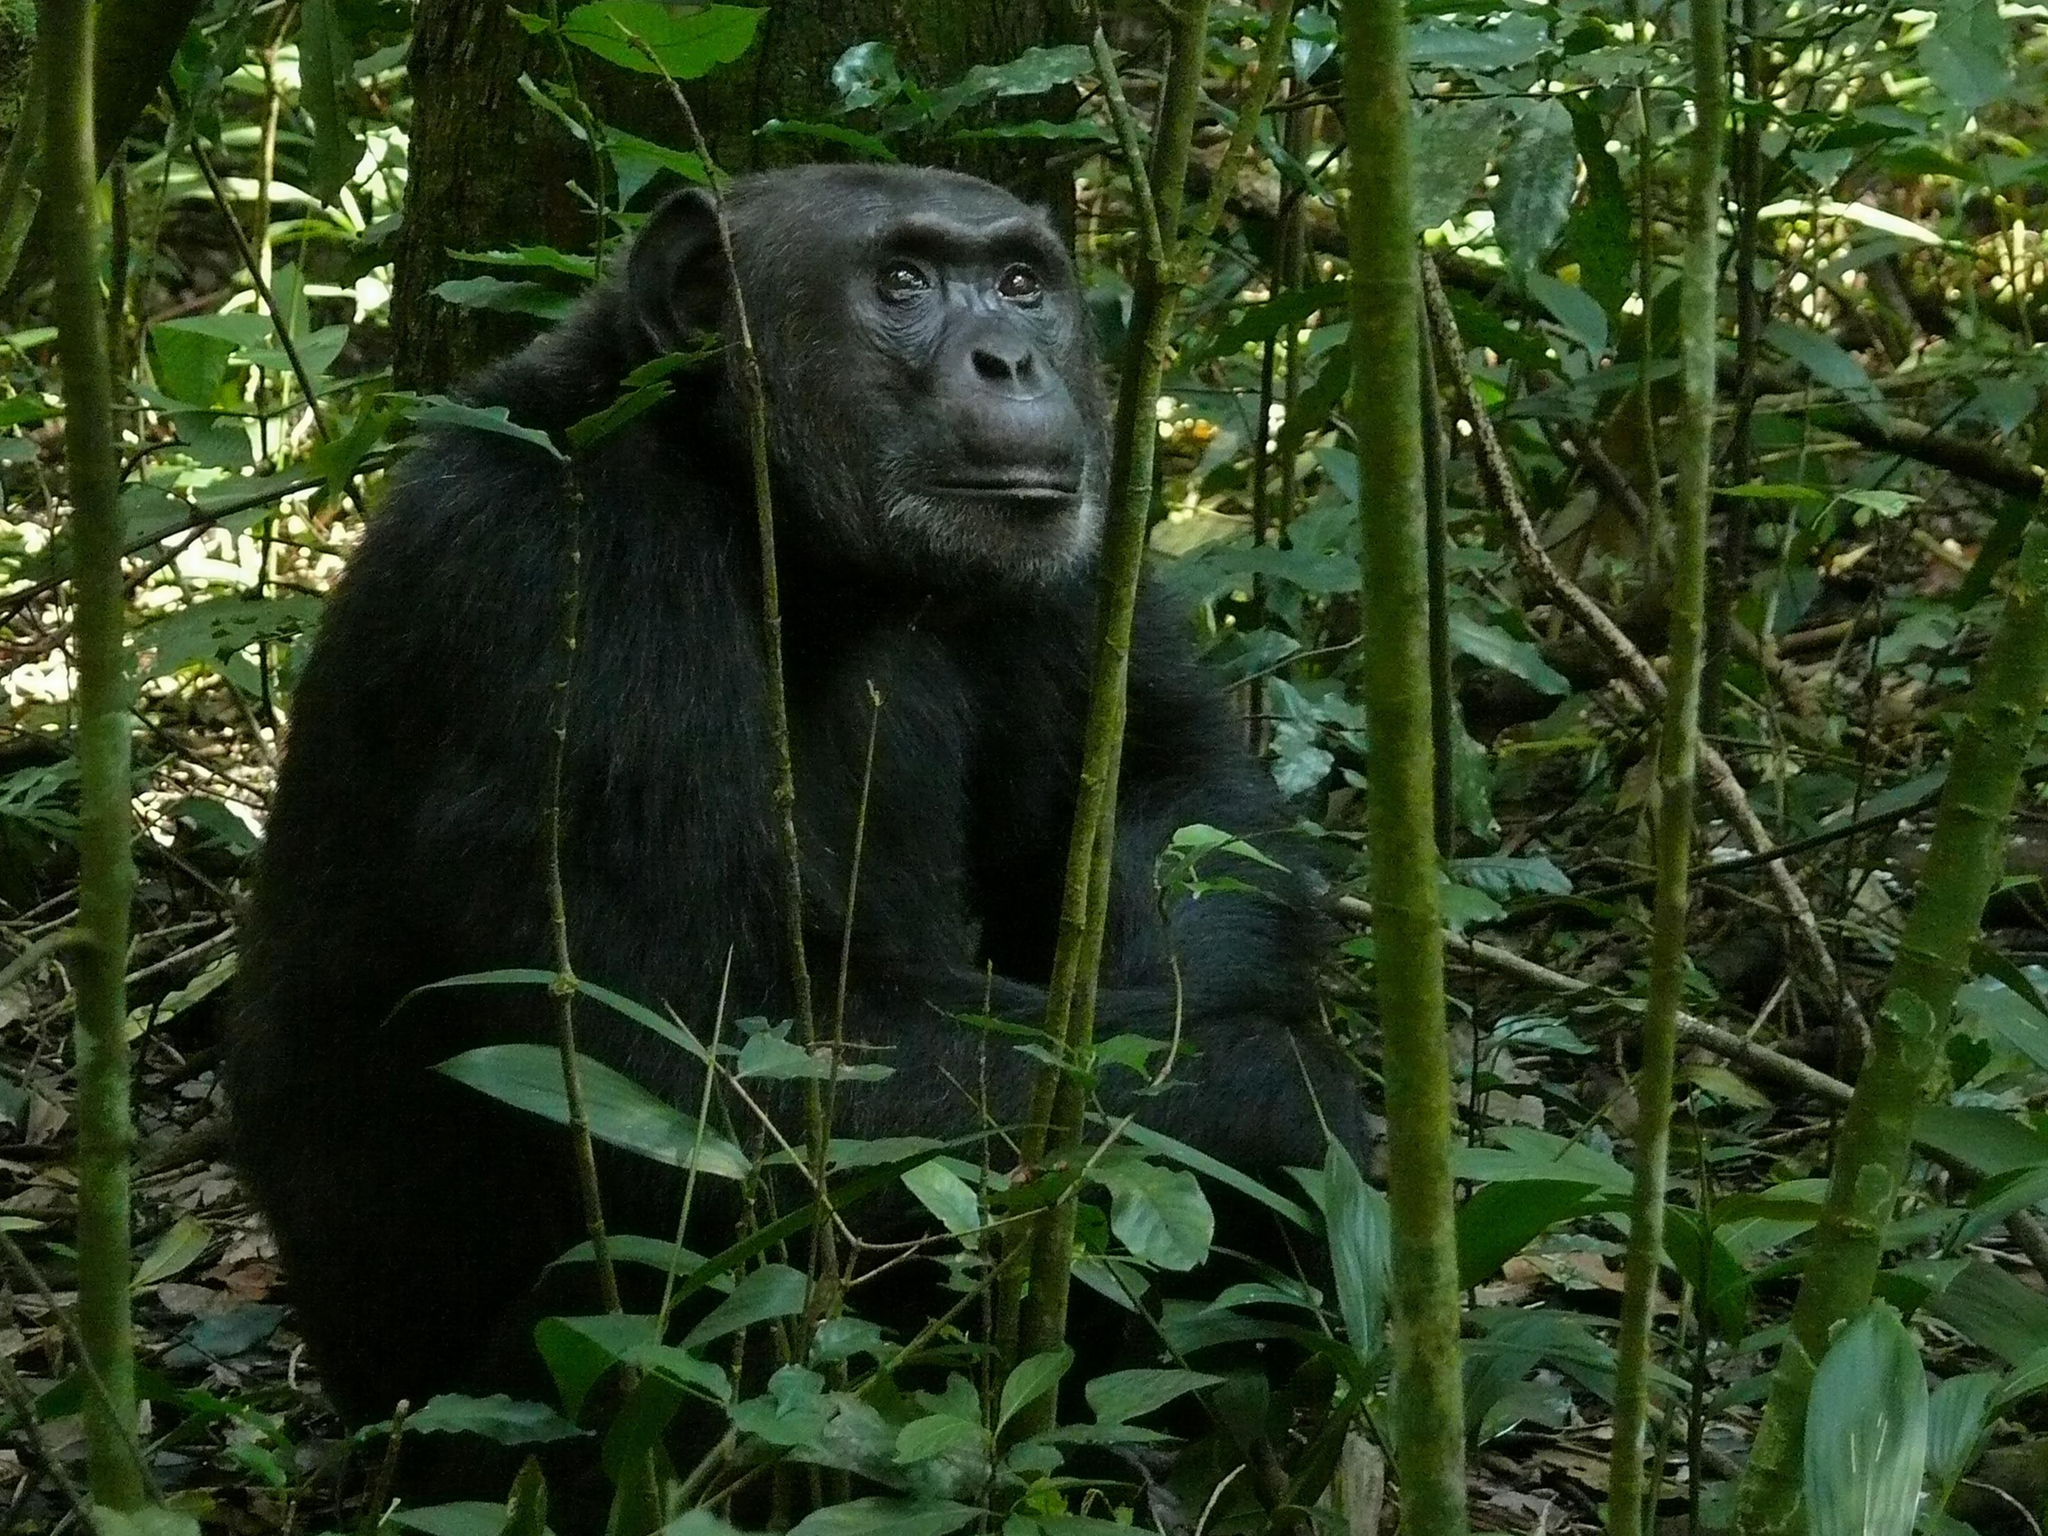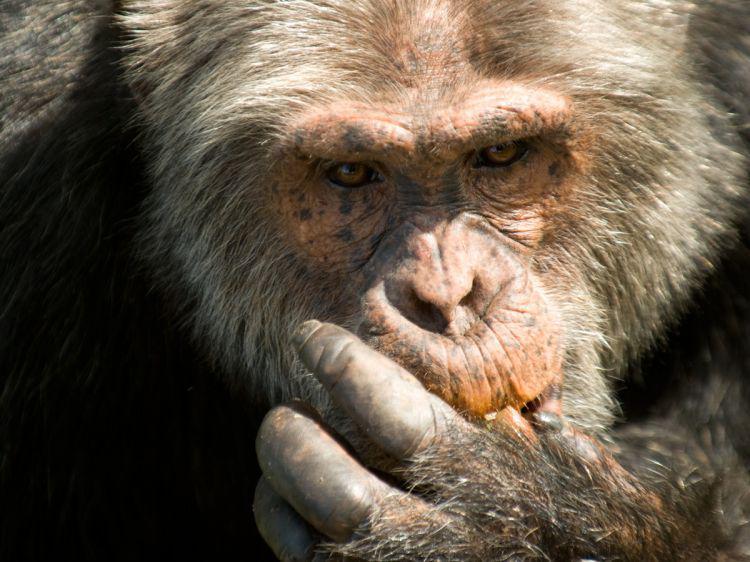The first image is the image on the left, the second image is the image on the right. For the images shown, is this caption "The right image shows a chimp looking down over a curved branch from a treetop vantage point." true? Answer yes or no. No. The first image is the image on the left, the second image is the image on the right. Examine the images to the left and right. Is the description "The primate in the image on the right is sitting on a tree branch." accurate? Answer yes or no. No. 